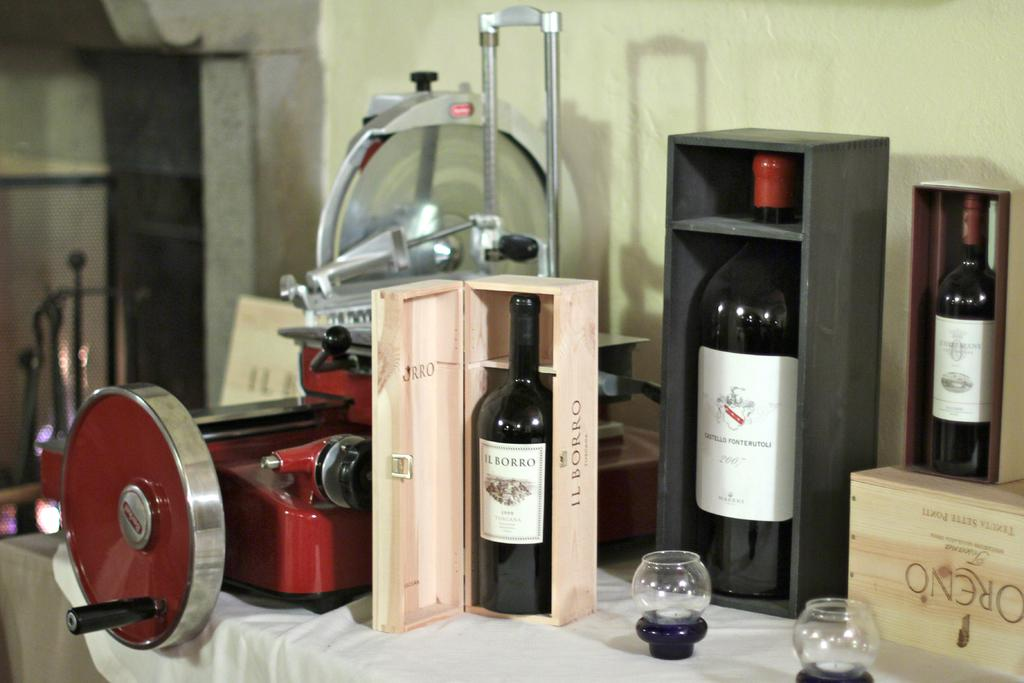<image>
Share a concise interpretation of the image provided. table with a red machine and 3 boxes of wine including il borro 